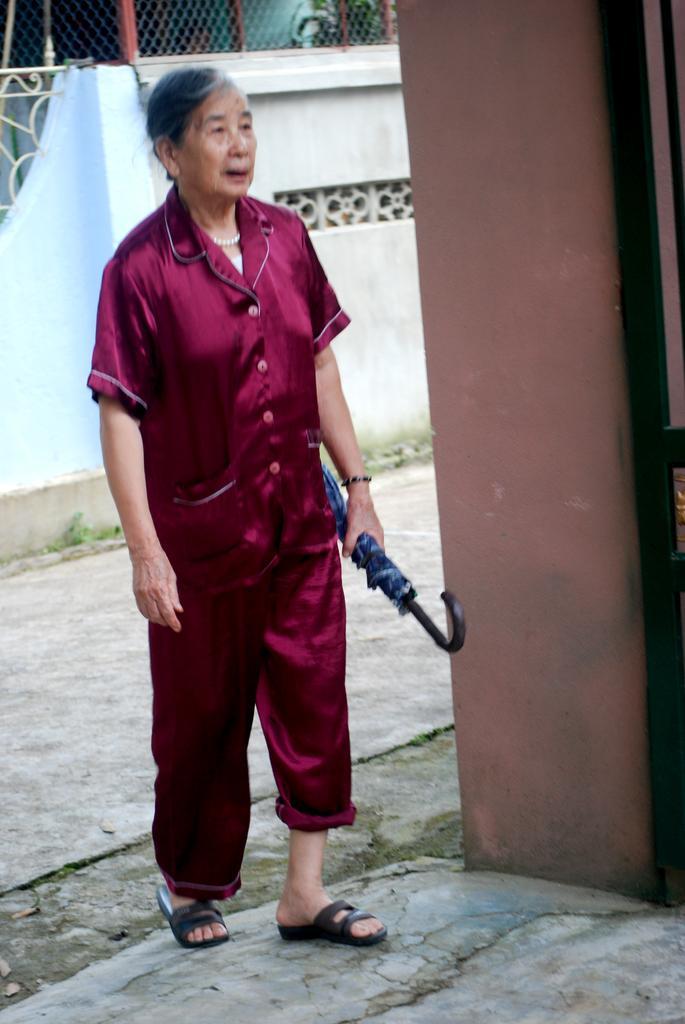Please provide a concise description of this image. In the middle I can see a woman is walking on the floor and is holding an umbrella in hand. In the background I can see a wall, fence and houses. This image is taken may be during a day. 